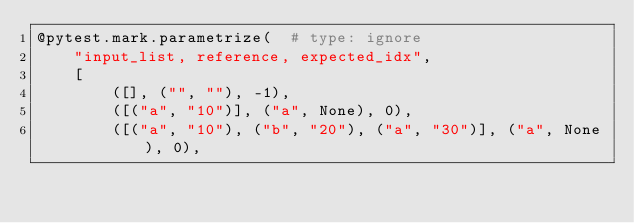Convert code to text. <code><loc_0><loc_0><loc_500><loc_500><_Python_>@pytest.mark.parametrize(  # type: ignore
    "input_list, reference, expected_idx",
    [
        ([], ("", ""), -1),
        ([("a", "10")], ("a", None), 0),
        ([("a", "10"), ("b", "20"), ("a", "30")], ("a", None), 0),</code> 